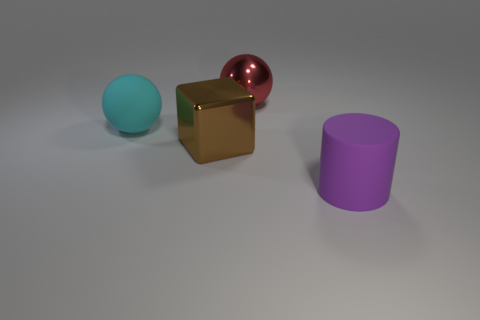Are there any purple rubber cylinders to the left of the big cyan ball?
Provide a short and direct response. No. Is the material of the cyan thing the same as the large sphere that is right of the brown block?
Offer a terse response. No. There is a purple object to the right of the big brown object; is its shape the same as the large cyan rubber thing?
Make the answer very short. No. What number of big brown cubes are the same material as the purple object?
Offer a very short reply. 0. What number of objects are either large objects that are in front of the big red sphere or large yellow matte things?
Your answer should be very brief. 3. The cyan matte sphere has what size?
Your answer should be very brief. Large. What is the material of the thing right of the big shiny object behind the big block?
Offer a terse response. Rubber. There is a rubber thing in front of the cyan rubber object; does it have the same size as the brown shiny block?
Offer a terse response. Yes. Is there a tiny cylinder of the same color as the big cube?
Ensure brevity in your answer.  No. How many objects are large things behind the big matte cylinder or red things to the right of the cyan ball?
Your response must be concise. 3. 